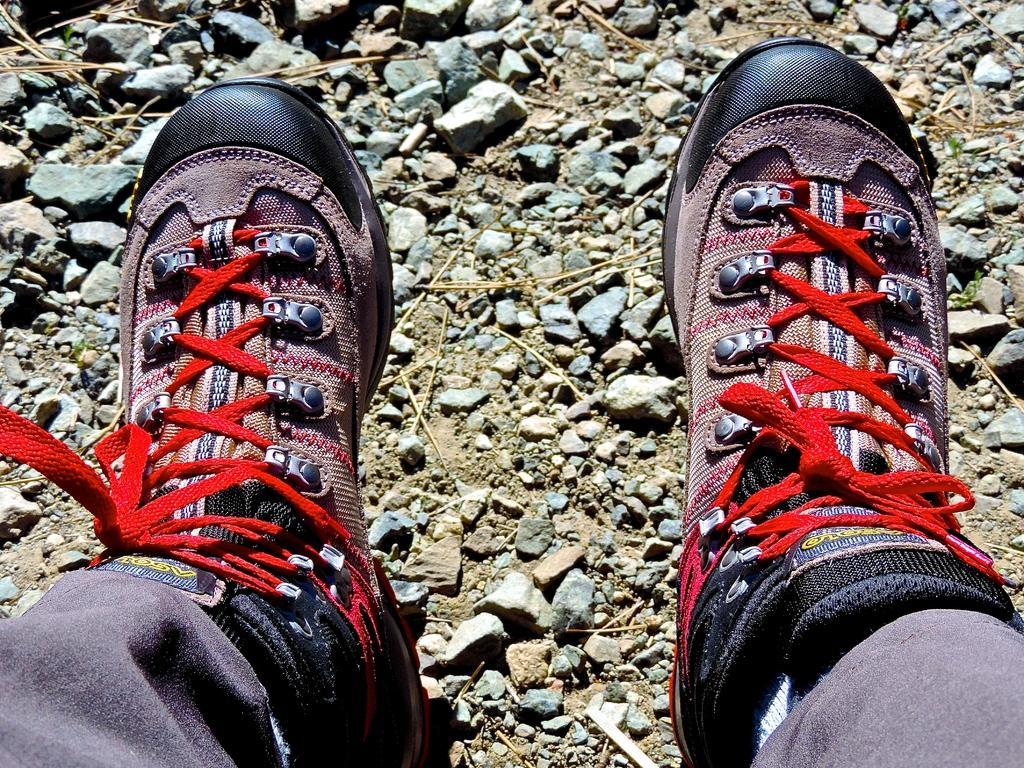How would you summarize this image in a sentence or two? In this picture I can see a human wore shoes and I can see stones on the ground. 